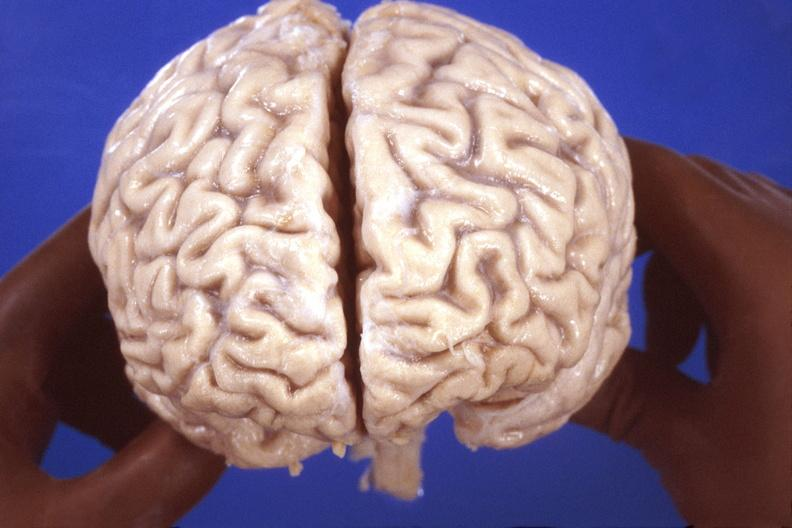does this image show brain, hiv neuropathy, atrophy?
Answer the question using a single word or phrase. Yes 